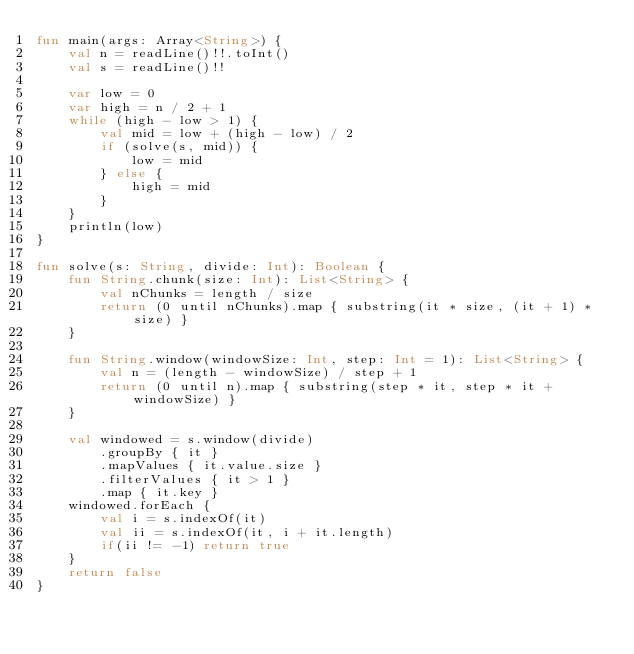<code> <loc_0><loc_0><loc_500><loc_500><_Kotlin_>fun main(args: Array<String>) {
    val n = readLine()!!.toInt()
    val s = readLine()!!

    var low = 0
    var high = n / 2 + 1
    while (high - low > 1) {
        val mid = low + (high - low) / 2
        if (solve(s, mid)) {
            low = mid
        } else {
            high = mid
        }
    }
    println(low)
}

fun solve(s: String, divide: Int): Boolean {
    fun String.chunk(size: Int): List<String> {
        val nChunks = length / size
        return (0 until nChunks).map { substring(it * size, (it + 1) * size) }
    }

    fun String.window(windowSize: Int, step: Int = 1): List<String> {
        val n = (length - windowSize) / step + 1
        return (0 until n).map { substring(step * it, step * it + windowSize) }
    }

    val windowed = s.window(divide)
        .groupBy { it }
        .mapValues { it.value.size }
        .filterValues { it > 1 }
        .map { it.key }
    windowed.forEach {
        val i = s.indexOf(it)
        val ii = s.indexOf(it, i + it.length)
        if(ii != -1) return true
    }
    return false
}
</code> 